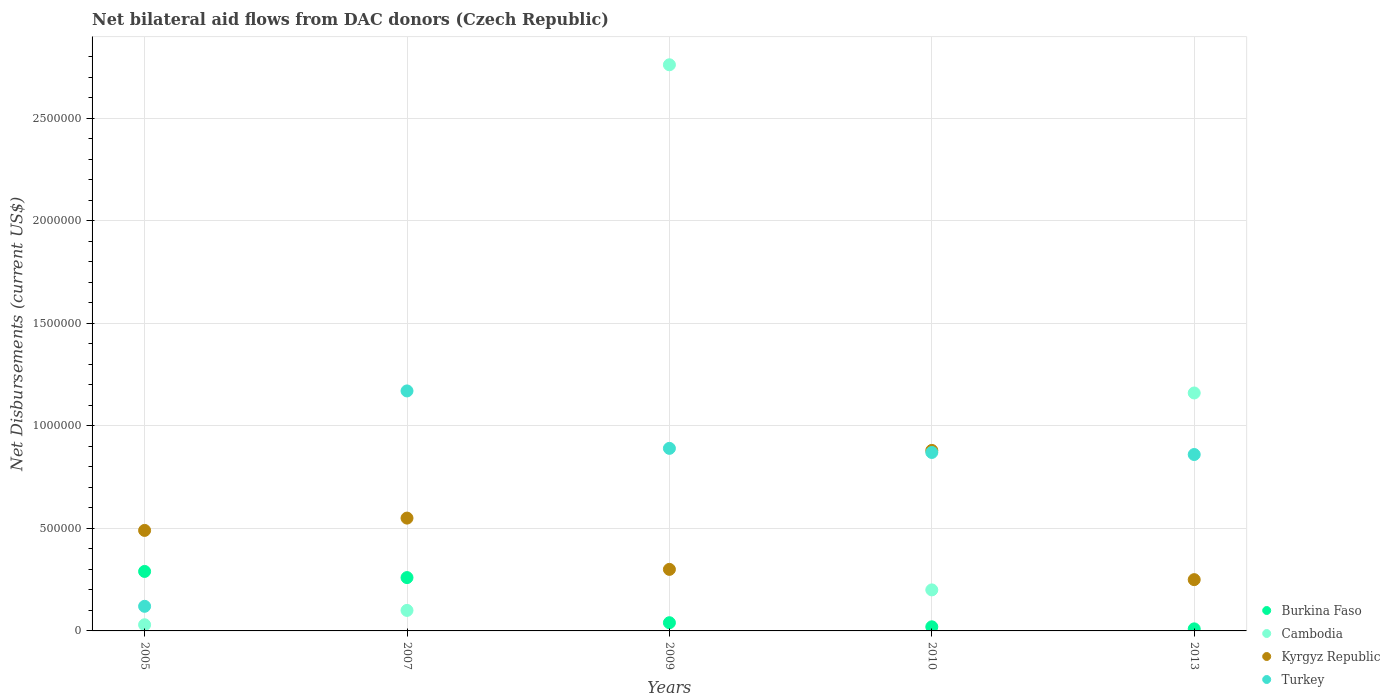Is the number of dotlines equal to the number of legend labels?
Make the answer very short. Yes. What is the net bilateral aid flows in Cambodia in 2005?
Ensure brevity in your answer.  3.00e+04. Across all years, what is the maximum net bilateral aid flows in Kyrgyz Republic?
Your answer should be very brief. 8.80e+05. Across all years, what is the minimum net bilateral aid flows in Turkey?
Provide a short and direct response. 1.20e+05. In which year was the net bilateral aid flows in Burkina Faso maximum?
Give a very brief answer. 2005. What is the total net bilateral aid flows in Turkey in the graph?
Offer a terse response. 3.91e+06. What is the difference between the net bilateral aid flows in Turkey in 2005 and that in 2013?
Your answer should be very brief. -7.40e+05. What is the difference between the net bilateral aid flows in Burkina Faso in 2013 and the net bilateral aid flows in Turkey in 2010?
Your answer should be compact. -8.60e+05. What is the average net bilateral aid flows in Cambodia per year?
Give a very brief answer. 8.50e+05. In the year 2010, what is the difference between the net bilateral aid flows in Kyrgyz Republic and net bilateral aid flows in Turkey?
Your answer should be compact. 10000. In how many years, is the net bilateral aid flows in Burkina Faso greater than 600000 US$?
Your answer should be compact. 0. What is the ratio of the net bilateral aid flows in Kyrgyz Republic in 2005 to that in 2013?
Make the answer very short. 1.96. Is the difference between the net bilateral aid flows in Kyrgyz Republic in 2010 and 2013 greater than the difference between the net bilateral aid flows in Turkey in 2010 and 2013?
Provide a short and direct response. Yes. What is the difference between the highest and the lowest net bilateral aid flows in Turkey?
Provide a succinct answer. 1.05e+06. In how many years, is the net bilateral aid flows in Kyrgyz Republic greater than the average net bilateral aid flows in Kyrgyz Republic taken over all years?
Offer a terse response. 2. Is it the case that in every year, the sum of the net bilateral aid flows in Kyrgyz Republic and net bilateral aid flows in Turkey  is greater than the sum of net bilateral aid flows in Cambodia and net bilateral aid flows in Burkina Faso?
Give a very brief answer. No. Is it the case that in every year, the sum of the net bilateral aid flows in Kyrgyz Republic and net bilateral aid flows in Burkina Faso  is greater than the net bilateral aid flows in Cambodia?
Ensure brevity in your answer.  No. Is the net bilateral aid flows in Turkey strictly less than the net bilateral aid flows in Burkina Faso over the years?
Provide a succinct answer. No. What is the difference between two consecutive major ticks on the Y-axis?
Keep it short and to the point. 5.00e+05. Does the graph contain any zero values?
Your answer should be very brief. No. What is the title of the graph?
Provide a short and direct response. Net bilateral aid flows from DAC donors (Czech Republic). Does "Suriname" appear as one of the legend labels in the graph?
Provide a succinct answer. No. What is the label or title of the Y-axis?
Your response must be concise. Net Disbursements (current US$). What is the Net Disbursements (current US$) in Cambodia in 2005?
Your answer should be very brief. 3.00e+04. What is the Net Disbursements (current US$) of Kyrgyz Republic in 2005?
Provide a succinct answer. 4.90e+05. What is the Net Disbursements (current US$) of Turkey in 2005?
Offer a terse response. 1.20e+05. What is the Net Disbursements (current US$) of Cambodia in 2007?
Your answer should be very brief. 1.00e+05. What is the Net Disbursements (current US$) in Kyrgyz Republic in 2007?
Your answer should be compact. 5.50e+05. What is the Net Disbursements (current US$) of Turkey in 2007?
Offer a terse response. 1.17e+06. What is the Net Disbursements (current US$) in Burkina Faso in 2009?
Provide a short and direct response. 4.00e+04. What is the Net Disbursements (current US$) in Cambodia in 2009?
Make the answer very short. 2.76e+06. What is the Net Disbursements (current US$) of Turkey in 2009?
Ensure brevity in your answer.  8.90e+05. What is the Net Disbursements (current US$) in Burkina Faso in 2010?
Your answer should be compact. 2.00e+04. What is the Net Disbursements (current US$) in Cambodia in 2010?
Provide a succinct answer. 2.00e+05. What is the Net Disbursements (current US$) of Kyrgyz Republic in 2010?
Give a very brief answer. 8.80e+05. What is the Net Disbursements (current US$) in Turkey in 2010?
Ensure brevity in your answer.  8.70e+05. What is the Net Disbursements (current US$) in Cambodia in 2013?
Provide a succinct answer. 1.16e+06. What is the Net Disbursements (current US$) in Turkey in 2013?
Offer a terse response. 8.60e+05. Across all years, what is the maximum Net Disbursements (current US$) of Cambodia?
Give a very brief answer. 2.76e+06. Across all years, what is the maximum Net Disbursements (current US$) of Kyrgyz Republic?
Make the answer very short. 8.80e+05. Across all years, what is the maximum Net Disbursements (current US$) in Turkey?
Offer a terse response. 1.17e+06. Across all years, what is the minimum Net Disbursements (current US$) of Burkina Faso?
Your response must be concise. 10000. Across all years, what is the minimum Net Disbursements (current US$) of Cambodia?
Provide a succinct answer. 3.00e+04. Across all years, what is the minimum Net Disbursements (current US$) in Turkey?
Make the answer very short. 1.20e+05. What is the total Net Disbursements (current US$) in Burkina Faso in the graph?
Your answer should be very brief. 6.20e+05. What is the total Net Disbursements (current US$) of Cambodia in the graph?
Provide a short and direct response. 4.25e+06. What is the total Net Disbursements (current US$) in Kyrgyz Republic in the graph?
Offer a terse response. 2.47e+06. What is the total Net Disbursements (current US$) in Turkey in the graph?
Ensure brevity in your answer.  3.91e+06. What is the difference between the Net Disbursements (current US$) in Burkina Faso in 2005 and that in 2007?
Your answer should be very brief. 3.00e+04. What is the difference between the Net Disbursements (current US$) in Cambodia in 2005 and that in 2007?
Offer a terse response. -7.00e+04. What is the difference between the Net Disbursements (current US$) in Kyrgyz Republic in 2005 and that in 2007?
Keep it short and to the point. -6.00e+04. What is the difference between the Net Disbursements (current US$) of Turkey in 2005 and that in 2007?
Offer a terse response. -1.05e+06. What is the difference between the Net Disbursements (current US$) of Burkina Faso in 2005 and that in 2009?
Give a very brief answer. 2.50e+05. What is the difference between the Net Disbursements (current US$) of Cambodia in 2005 and that in 2009?
Provide a succinct answer. -2.73e+06. What is the difference between the Net Disbursements (current US$) of Turkey in 2005 and that in 2009?
Your answer should be very brief. -7.70e+05. What is the difference between the Net Disbursements (current US$) of Burkina Faso in 2005 and that in 2010?
Your response must be concise. 2.70e+05. What is the difference between the Net Disbursements (current US$) of Kyrgyz Republic in 2005 and that in 2010?
Ensure brevity in your answer.  -3.90e+05. What is the difference between the Net Disbursements (current US$) of Turkey in 2005 and that in 2010?
Make the answer very short. -7.50e+05. What is the difference between the Net Disbursements (current US$) of Cambodia in 2005 and that in 2013?
Offer a terse response. -1.13e+06. What is the difference between the Net Disbursements (current US$) of Turkey in 2005 and that in 2013?
Your answer should be very brief. -7.40e+05. What is the difference between the Net Disbursements (current US$) in Cambodia in 2007 and that in 2009?
Your response must be concise. -2.66e+06. What is the difference between the Net Disbursements (current US$) in Kyrgyz Republic in 2007 and that in 2009?
Offer a very short reply. 2.50e+05. What is the difference between the Net Disbursements (current US$) of Burkina Faso in 2007 and that in 2010?
Ensure brevity in your answer.  2.40e+05. What is the difference between the Net Disbursements (current US$) of Kyrgyz Republic in 2007 and that in 2010?
Give a very brief answer. -3.30e+05. What is the difference between the Net Disbursements (current US$) of Turkey in 2007 and that in 2010?
Provide a succinct answer. 3.00e+05. What is the difference between the Net Disbursements (current US$) of Burkina Faso in 2007 and that in 2013?
Ensure brevity in your answer.  2.50e+05. What is the difference between the Net Disbursements (current US$) in Cambodia in 2007 and that in 2013?
Your answer should be very brief. -1.06e+06. What is the difference between the Net Disbursements (current US$) of Kyrgyz Republic in 2007 and that in 2013?
Make the answer very short. 3.00e+05. What is the difference between the Net Disbursements (current US$) in Cambodia in 2009 and that in 2010?
Offer a terse response. 2.56e+06. What is the difference between the Net Disbursements (current US$) in Kyrgyz Republic in 2009 and that in 2010?
Ensure brevity in your answer.  -5.80e+05. What is the difference between the Net Disbursements (current US$) of Turkey in 2009 and that in 2010?
Give a very brief answer. 2.00e+04. What is the difference between the Net Disbursements (current US$) of Cambodia in 2009 and that in 2013?
Offer a terse response. 1.60e+06. What is the difference between the Net Disbursements (current US$) of Kyrgyz Republic in 2009 and that in 2013?
Offer a terse response. 5.00e+04. What is the difference between the Net Disbursements (current US$) in Cambodia in 2010 and that in 2013?
Your response must be concise. -9.60e+05. What is the difference between the Net Disbursements (current US$) of Kyrgyz Republic in 2010 and that in 2013?
Make the answer very short. 6.30e+05. What is the difference between the Net Disbursements (current US$) of Turkey in 2010 and that in 2013?
Make the answer very short. 10000. What is the difference between the Net Disbursements (current US$) in Burkina Faso in 2005 and the Net Disbursements (current US$) in Cambodia in 2007?
Offer a terse response. 1.90e+05. What is the difference between the Net Disbursements (current US$) of Burkina Faso in 2005 and the Net Disbursements (current US$) of Turkey in 2007?
Provide a succinct answer. -8.80e+05. What is the difference between the Net Disbursements (current US$) of Cambodia in 2005 and the Net Disbursements (current US$) of Kyrgyz Republic in 2007?
Make the answer very short. -5.20e+05. What is the difference between the Net Disbursements (current US$) of Cambodia in 2005 and the Net Disbursements (current US$) of Turkey in 2007?
Provide a short and direct response. -1.14e+06. What is the difference between the Net Disbursements (current US$) of Kyrgyz Republic in 2005 and the Net Disbursements (current US$) of Turkey in 2007?
Provide a succinct answer. -6.80e+05. What is the difference between the Net Disbursements (current US$) of Burkina Faso in 2005 and the Net Disbursements (current US$) of Cambodia in 2009?
Your response must be concise. -2.47e+06. What is the difference between the Net Disbursements (current US$) in Burkina Faso in 2005 and the Net Disbursements (current US$) in Turkey in 2009?
Your answer should be very brief. -6.00e+05. What is the difference between the Net Disbursements (current US$) of Cambodia in 2005 and the Net Disbursements (current US$) of Kyrgyz Republic in 2009?
Provide a succinct answer. -2.70e+05. What is the difference between the Net Disbursements (current US$) in Cambodia in 2005 and the Net Disbursements (current US$) in Turkey in 2009?
Offer a terse response. -8.60e+05. What is the difference between the Net Disbursements (current US$) of Kyrgyz Republic in 2005 and the Net Disbursements (current US$) of Turkey in 2009?
Provide a short and direct response. -4.00e+05. What is the difference between the Net Disbursements (current US$) in Burkina Faso in 2005 and the Net Disbursements (current US$) in Kyrgyz Republic in 2010?
Offer a very short reply. -5.90e+05. What is the difference between the Net Disbursements (current US$) in Burkina Faso in 2005 and the Net Disbursements (current US$) in Turkey in 2010?
Offer a very short reply. -5.80e+05. What is the difference between the Net Disbursements (current US$) of Cambodia in 2005 and the Net Disbursements (current US$) of Kyrgyz Republic in 2010?
Offer a very short reply. -8.50e+05. What is the difference between the Net Disbursements (current US$) of Cambodia in 2005 and the Net Disbursements (current US$) of Turkey in 2010?
Your answer should be compact. -8.40e+05. What is the difference between the Net Disbursements (current US$) in Kyrgyz Republic in 2005 and the Net Disbursements (current US$) in Turkey in 2010?
Your answer should be very brief. -3.80e+05. What is the difference between the Net Disbursements (current US$) of Burkina Faso in 2005 and the Net Disbursements (current US$) of Cambodia in 2013?
Your response must be concise. -8.70e+05. What is the difference between the Net Disbursements (current US$) of Burkina Faso in 2005 and the Net Disbursements (current US$) of Turkey in 2013?
Your response must be concise. -5.70e+05. What is the difference between the Net Disbursements (current US$) of Cambodia in 2005 and the Net Disbursements (current US$) of Turkey in 2013?
Keep it short and to the point. -8.30e+05. What is the difference between the Net Disbursements (current US$) of Kyrgyz Republic in 2005 and the Net Disbursements (current US$) of Turkey in 2013?
Offer a very short reply. -3.70e+05. What is the difference between the Net Disbursements (current US$) of Burkina Faso in 2007 and the Net Disbursements (current US$) of Cambodia in 2009?
Your answer should be compact. -2.50e+06. What is the difference between the Net Disbursements (current US$) in Burkina Faso in 2007 and the Net Disbursements (current US$) in Kyrgyz Republic in 2009?
Keep it short and to the point. -4.00e+04. What is the difference between the Net Disbursements (current US$) of Burkina Faso in 2007 and the Net Disbursements (current US$) of Turkey in 2009?
Keep it short and to the point. -6.30e+05. What is the difference between the Net Disbursements (current US$) of Cambodia in 2007 and the Net Disbursements (current US$) of Turkey in 2009?
Offer a very short reply. -7.90e+05. What is the difference between the Net Disbursements (current US$) of Kyrgyz Republic in 2007 and the Net Disbursements (current US$) of Turkey in 2009?
Your answer should be compact. -3.40e+05. What is the difference between the Net Disbursements (current US$) in Burkina Faso in 2007 and the Net Disbursements (current US$) in Cambodia in 2010?
Ensure brevity in your answer.  6.00e+04. What is the difference between the Net Disbursements (current US$) of Burkina Faso in 2007 and the Net Disbursements (current US$) of Kyrgyz Republic in 2010?
Provide a short and direct response. -6.20e+05. What is the difference between the Net Disbursements (current US$) in Burkina Faso in 2007 and the Net Disbursements (current US$) in Turkey in 2010?
Your answer should be compact. -6.10e+05. What is the difference between the Net Disbursements (current US$) of Cambodia in 2007 and the Net Disbursements (current US$) of Kyrgyz Republic in 2010?
Ensure brevity in your answer.  -7.80e+05. What is the difference between the Net Disbursements (current US$) in Cambodia in 2007 and the Net Disbursements (current US$) in Turkey in 2010?
Provide a succinct answer. -7.70e+05. What is the difference between the Net Disbursements (current US$) in Kyrgyz Republic in 2007 and the Net Disbursements (current US$) in Turkey in 2010?
Ensure brevity in your answer.  -3.20e+05. What is the difference between the Net Disbursements (current US$) in Burkina Faso in 2007 and the Net Disbursements (current US$) in Cambodia in 2013?
Give a very brief answer. -9.00e+05. What is the difference between the Net Disbursements (current US$) of Burkina Faso in 2007 and the Net Disbursements (current US$) of Turkey in 2013?
Offer a very short reply. -6.00e+05. What is the difference between the Net Disbursements (current US$) in Cambodia in 2007 and the Net Disbursements (current US$) in Kyrgyz Republic in 2013?
Provide a succinct answer. -1.50e+05. What is the difference between the Net Disbursements (current US$) of Cambodia in 2007 and the Net Disbursements (current US$) of Turkey in 2013?
Offer a very short reply. -7.60e+05. What is the difference between the Net Disbursements (current US$) of Kyrgyz Republic in 2007 and the Net Disbursements (current US$) of Turkey in 2013?
Your answer should be compact. -3.10e+05. What is the difference between the Net Disbursements (current US$) of Burkina Faso in 2009 and the Net Disbursements (current US$) of Cambodia in 2010?
Ensure brevity in your answer.  -1.60e+05. What is the difference between the Net Disbursements (current US$) of Burkina Faso in 2009 and the Net Disbursements (current US$) of Kyrgyz Republic in 2010?
Your answer should be very brief. -8.40e+05. What is the difference between the Net Disbursements (current US$) of Burkina Faso in 2009 and the Net Disbursements (current US$) of Turkey in 2010?
Offer a very short reply. -8.30e+05. What is the difference between the Net Disbursements (current US$) in Cambodia in 2009 and the Net Disbursements (current US$) in Kyrgyz Republic in 2010?
Your answer should be compact. 1.88e+06. What is the difference between the Net Disbursements (current US$) of Cambodia in 2009 and the Net Disbursements (current US$) of Turkey in 2010?
Give a very brief answer. 1.89e+06. What is the difference between the Net Disbursements (current US$) in Kyrgyz Republic in 2009 and the Net Disbursements (current US$) in Turkey in 2010?
Your answer should be compact. -5.70e+05. What is the difference between the Net Disbursements (current US$) in Burkina Faso in 2009 and the Net Disbursements (current US$) in Cambodia in 2013?
Your answer should be compact. -1.12e+06. What is the difference between the Net Disbursements (current US$) in Burkina Faso in 2009 and the Net Disbursements (current US$) in Kyrgyz Republic in 2013?
Offer a terse response. -2.10e+05. What is the difference between the Net Disbursements (current US$) of Burkina Faso in 2009 and the Net Disbursements (current US$) of Turkey in 2013?
Provide a succinct answer. -8.20e+05. What is the difference between the Net Disbursements (current US$) of Cambodia in 2009 and the Net Disbursements (current US$) of Kyrgyz Republic in 2013?
Ensure brevity in your answer.  2.51e+06. What is the difference between the Net Disbursements (current US$) of Cambodia in 2009 and the Net Disbursements (current US$) of Turkey in 2013?
Your answer should be very brief. 1.90e+06. What is the difference between the Net Disbursements (current US$) of Kyrgyz Republic in 2009 and the Net Disbursements (current US$) of Turkey in 2013?
Keep it short and to the point. -5.60e+05. What is the difference between the Net Disbursements (current US$) in Burkina Faso in 2010 and the Net Disbursements (current US$) in Cambodia in 2013?
Offer a very short reply. -1.14e+06. What is the difference between the Net Disbursements (current US$) of Burkina Faso in 2010 and the Net Disbursements (current US$) of Turkey in 2013?
Your answer should be compact. -8.40e+05. What is the difference between the Net Disbursements (current US$) of Cambodia in 2010 and the Net Disbursements (current US$) of Turkey in 2013?
Provide a succinct answer. -6.60e+05. What is the difference between the Net Disbursements (current US$) in Kyrgyz Republic in 2010 and the Net Disbursements (current US$) in Turkey in 2013?
Keep it short and to the point. 2.00e+04. What is the average Net Disbursements (current US$) in Burkina Faso per year?
Provide a succinct answer. 1.24e+05. What is the average Net Disbursements (current US$) in Cambodia per year?
Keep it short and to the point. 8.50e+05. What is the average Net Disbursements (current US$) of Kyrgyz Republic per year?
Give a very brief answer. 4.94e+05. What is the average Net Disbursements (current US$) in Turkey per year?
Make the answer very short. 7.82e+05. In the year 2005, what is the difference between the Net Disbursements (current US$) of Burkina Faso and Net Disbursements (current US$) of Cambodia?
Keep it short and to the point. 2.60e+05. In the year 2005, what is the difference between the Net Disbursements (current US$) of Burkina Faso and Net Disbursements (current US$) of Kyrgyz Republic?
Your response must be concise. -2.00e+05. In the year 2005, what is the difference between the Net Disbursements (current US$) of Cambodia and Net Disbursements (current US$) of Kyrgyz Republic?
Offer a very short reply. -4.60e+05. In the year 2005, what is the difference between the Net Disbursements (current US$) in Kyrgyz Republic and Net Disbursements (current US$) in Turkey?
Offer a very short reply. 3.70e+05. In the year 2007, what is the difference between the Net Disbursements (current US$) of Burkina Faso and Net Disbursements (current US$) of Kyrgyz Republic?
Offer a very short reply. -2.90e+05. In the year 2007, what is the difference between the Net Disbursements (current US$) in Burkina Faso and Net Disbursements (current US$) in Turkey?
Keep it short and to the point. -9.10e+05. In the year 2007, what is the difference between the Net Disbursements (current US$) of Cambodia and Net Disbursements (current US$) of Kyrgyz Republic?
Offer a terse response. -4.50e+05. In the year 2007, what is the difference between the Net Disbursements (current US$) of Cambodia and Net Disbursements (current US$) of Turkey?
Offer a very short reply. -1.07e+06. In the year 2007, what is the difference between the Net Disbursements (current US$) in Kyrgyz Republic and Net Disbursements (current US$) in Turkey?
Offer a terse response. -6.20e+05. In the year 2009, what is the difference between the Net Disbursements (current US$) of Burkina Faso and Net Disbursements (current US$) of Cambodia?
Your answer should be compact. -2.72e+06. In the year 2009, what is the difference between the Net Disbursements (current US$) in Burkina Faso and Net Disbursements (current US$) in Turkey?
Ensure brevity in your answer.  -8.50e+05. In the year 2009, what is the difference between the Net Disbursements (current US$) in Cambodia and Net Disbursements (current US$) in Kyrgyz Republic?
Keep it short and to the point. 2.46e+06. In the year 2009, what is the difference between the Net Disbursements (current US$) in Cambodia and Net Disbursements (current US$) in Turkey?
Offer a very short reply. 1.87e+06. In the year 2009, what is the difference between the Net Disbursements (current US$) of Kyrgyz Republic and Net Disbursements (current US$) of Turkey?
Give a very brief answer. -5.90e+05. In the year 2010, what is the difference between the Net Disbursements (current US$) in Burkina Faso and Net Disbursements (current US$) in Kyrgyz Republic?
Keep it short and to the point. -8.60e+05. In the year 2010, what is the difference between the Net Disbursements (current US$) in Burkina Faso and Net Disbursements (current US$) in Turkey?
Your answer should be very brief. -8.50e+05. In the year 2010, what is the difference between the Net Disbursements (current US$) in Cambodia and Net Disbursements (current US$) in Kyrgyz Republic?
Offer a terse response. -6.80e+05. In the year 2010, what is the difference between the Net Disbursements (current US$) in Cambodia and Net Disbursements (current US$) in Turkey?
Keep it short and to the point. -6.70e+05. In the year 2013, what is the difference between the Net Disbursements (current US$) of Burkina Faso and Net Disbursements (current US$) of Cambodia?
Make the answer very short. -1.15e+06. In the year 2013, what is the difference between the Net Disbursements (current US$) of Burkina Faso and Net Disbursements (current US$) of Kyrgyz Republic?
Offer a terse response. -2.40e+05. In the year 2013, what is the difference between the Net Disbursements (current US$) of Burkina Faso and Net Disbursements (current US$) of Turkey?
Provide a succinct answer. -8.50e+05. In the year 2013, what is the difference between the Net Disbursements (current US$) in Cambodia and Net Disbursements (current US$) in Kyrgyz Republic?
Offer a terse response. 9.10e+05. In the year 2013, what is the difference between the Net Disbursements (current US$) in Kyrgyz Republic and Net Disbursements (current US$) in Turkey?
Your answer should be compact. -6.10e+05. What is the ratio of the Net Disbursements (current US$) in Burkina Faso in 2005 to that in 2007?
Provide a succinct answer. 1.12. What is the ratio of the Net Disbursements (current US$) of Cambodia in 2005 to that in 2007?
Give a very brief answer. 0.3. What is the ratio of the Net Disbursements (current US$) of Kyrgyz Republic in 2005 to that in 2007?
Make the answer very short. 0.89. What is the ratio of the Net Disbursements (current US$) in Turkey in 2005 to that in 2007?
Your response must be concise. 0.1. What is the ratio of the Net Disbursements (current US$) of Burkina Faso in 2005 to that in 2009?
Your answer should be very brief. 7.25. What is the ratio of the Net Disbursements (current US$) of Cambodia in 2005 to that in 2009?
Provide a succinct answer. 0.01. What is the ratio of the Net Disbursements (current US$) of Kyrgyz Republic in 2005 to that in 2009?
Provide a short and direct response. 1.63. What is the ratio of the Net Disbursements (current US$) in Turkey in 2005 to that in 2009?
Make the answer very short. 0.13. What is the ratio of the Net Disbursements (current US$) of Kyrgyz Republic in 2005 to that in 2010?
Your response must be concise. 0.56. What is the ratio of the Net Disbursements (current US$) in Turkey in 2005 to that in 2010?
Make the answer very short. 0.14. What is the ratio of the Net Disbursements (current US$) of Cambodia in 2005 to that in 2013?
Give a very brief answer. 0.03. What is the ratio of the Net Disbursements (current US$) of Kyrgyz Republic in 2005 to that in 2013?
Ensure brevity in your answer.  1.96. What is the ratio of the Net Disbursements (current US$) in Turkey in 2005 to that in 2013?
Make the answer very short. 0.14. What is the ratio of the Net Disbursements (current US$) in Cambodia in 2007 to that in 2009?
Make the answer very short. 0.04. What is the ratio of the Net Disbursements (current US$) in Kyrgyz Republic in 2007 to that in 2009?
Ensure brevity in your answer.  1.83. What is the ratio of the Net Disbursements (current US$) of Turkey in 2007 to that in 2009?
Give a very brief answer. 1.31. What is the ratio of the Net Disbursements (current US$) in Burkina Faso in 2007 to that in 2010?
Ensure brevity in your answer.  13. What is the ratio of the Net Disbursements (current US$) of Cambodia in 2007 to that in 2010?
Provide a short and direct response. 0.5. What is the ratio of the Net Disbursements (current US$) in Kyrgyz Republic in 2007 to that in 2010?
Provide a succinct answer. 0.62. What is the ratio of the Net Disbursements (current US$) of Turkey in 2007 to that in 2010?
Keep it short and to the point. 1.34. What is the ratio of the Net Disbursements (current US$) of Cambodia in 2007 to that in 2013?
Make the answer very short. 0.09. What is the ratio of the Net Disbursements (current US$) in Turkey in 2007 to that in 2013?
Offer a terse response. 1.36. What is the ratio of the Net Disbursements (current US$) in Cambodia in 2009 to that in 2010?
Keep it short and to the point. 13.8. What is the ratio of the Net Disbursements (current US$) in Kyrgyz Republic in 2009 to that in 2010?
Your answer should be very brief. 0.34. What is the ratio of the Net Disbursements (current US$) in Turkey in 2009 to that in 2010?
Give a very brief answer. 1.02. What is the ratio of the Net Disbursements (current US$) of Burkina Faso in 2009 to that in 2013?
Your answer should be compact. 4. What is the ratio of the Net Disbursements (current US$) in Cambodia in 2009 to that in 2013?
Your answer should be compact. 2.38. What is the ratio of the Net Disbursements (current US$) in Kyrgyz Republic in 2009 to that in 2013?
Make the answer very short. 1.2. What is the ratio of the Net Disbursements (current US$) of Turkey in 2009 to that in 2013?
Keep it short and to the point. 1.03. What is the ratio of the Net Disbursements (current US$) of Burkina Faso in 2010 to that in 2013?
Provide a short and direct response. 2. What is the ratio of the Net Disbursements (current US$) of Cambodia in 2010 to that in 2013?
Provide a short and direct response. 0.17. What is the ratio of the Net Disbursements (current US$) in Kyrgyz Republic in 2010 to that in 2013?
Provide a short and direct response. 3.52. What is the ratio of the Net Disbursements (current US$) of Turkey in 2010 to that in 2013?
Provide a succinct answer. 1.01. What is the difference between the highest and the second highest Net Disbursements (current US$) in Burkina Faso?
Your answer should be very brief. 3.00e+04. What is the difference between the highest and the second highest Net Disbursements (current US$) in Cambodia?
Offer a terse response. 1.60e+06. What is the difference between the highest and the lowest Net Disbursements (current US$) in Cambodia?
Your answer should be very brief. 2.73e+06. What is the difference between the highest and the lowest Net Disbursements (current US$) of Kyrgyz Republic?
Give a very brief answer. 6.30e+05. What is the difference between the highest and the lowest Net Disbursements (current US$) of Turkey?
Offer a very short reply. 1.05e+06. 